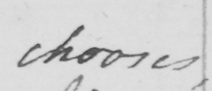Please transcribe the handwritten text in this image. chooses , 